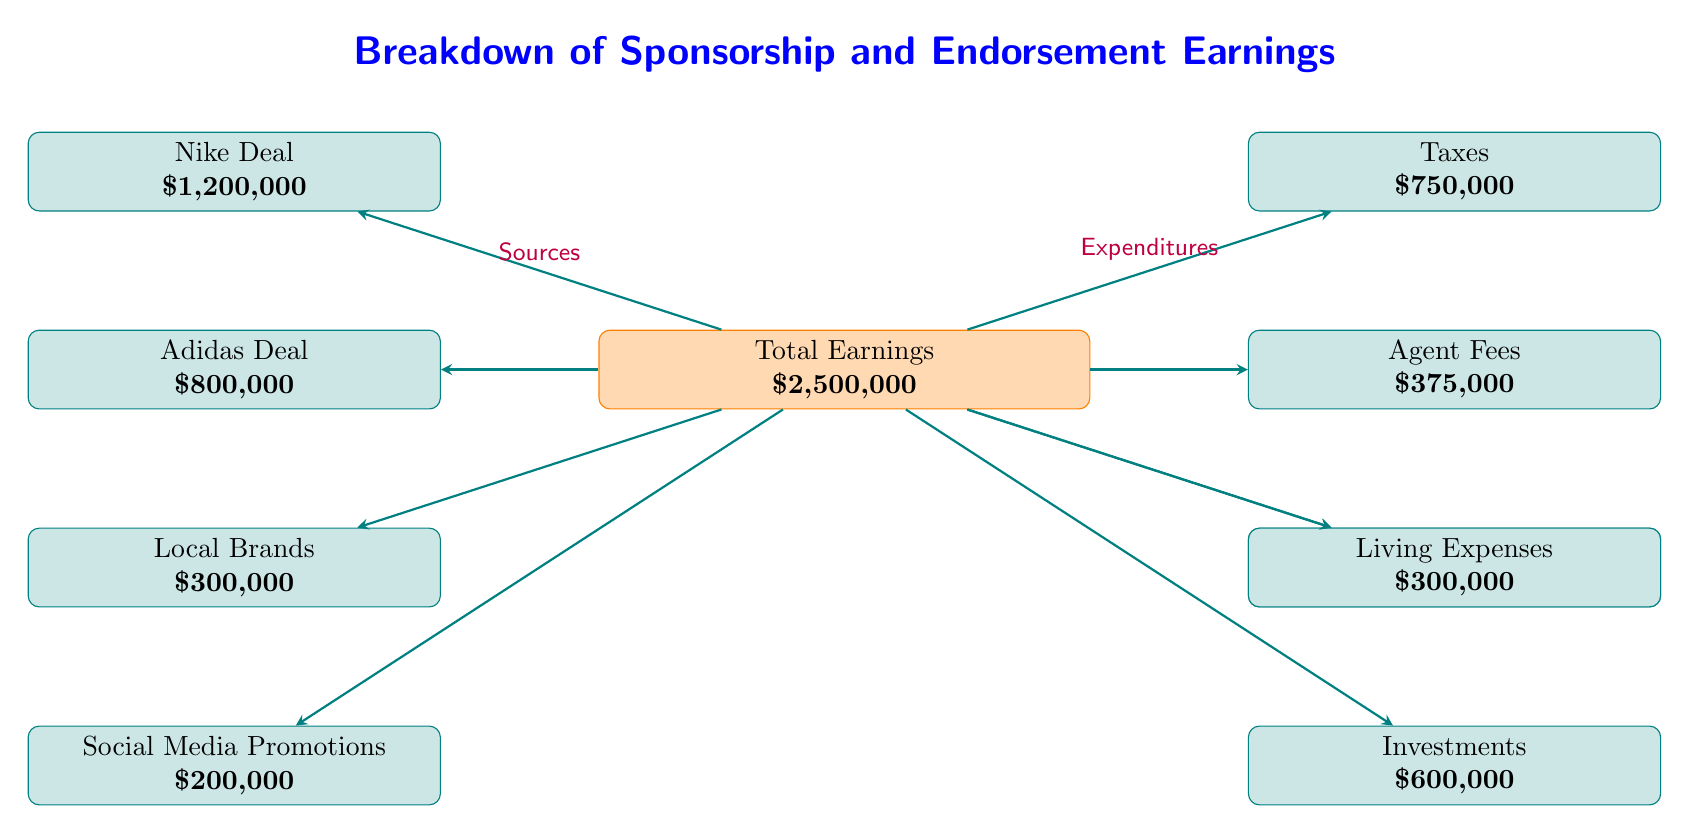What is the total earnings amount? The total earnings node is clearly labeled in the center of the diagram, stating that the total earnings amount is 2,500,000.
Answer: 2,500,000 How much does the Adidas deal contribute to total earnings? The Adidas deal is one of the sources shown on the left side of the total earnings node, and it is labeled as contributing 800,000.
Answer: 800,000 What percentage of total earnings comes from the Nike deal? The Nike deal amount is 1,200,000 and the total earnings amount is 2,500,000. To find the percentage, divide the Nike deal amount by total earnings and multiply by 100: (1,200,000 / 2,500,000) * 100 = 48%.
Answer: 48% What are the total expenditures? The expenditures are represented by the nodes branching out from the total earnings node on the right side. By adding the amounts listed: 750,000 (Taxes) + 375,000 (Agent Fees) + 150,000 (Legal Fees) + 300,000 (Living Expenses) + 600,000 (Investments), the total is 2,175,000.
Answer: 2,175,000 Which expenditure category has the lowest amount? Among the listed expenditure nodes, Legal Fees is the lowest at 150,000, as indicated in the diagram.
Answer: Legal Fees What is the total amount from local brands and social media promotions? Local Brands contributes 300,000 and Social Media Promotions contributes 200,000. Adding these amounts gives a total of 500,000: 300,000 + 200,000.
Answer: 500,000 How many sources of income are shown? The sources of income are represented by the nodes branching from the total earnings node on the left side. There are four source nodes: Nike Deal, Adidas Deal, Local Brands, and Social Media Promotions.
Answer: 4 What is the total amount deducted for taxes and agent fees? To find the total amount deducted for Taxes and Agent Fees, add their respective amounts together: 750,000 (Taxes) + 375,000 (Agent Fees) = 1,125,000.
Answer: 1,125,000 What is the relationship between the totals of earnings and expenditures? The diagram indicates that total earnings of 2,500,000 are reduced by the total expenditure amount, which is calculated as 2,175,000. This shows that the earnings exceed expenditures.
Answer: Earnings exceed expenditures 